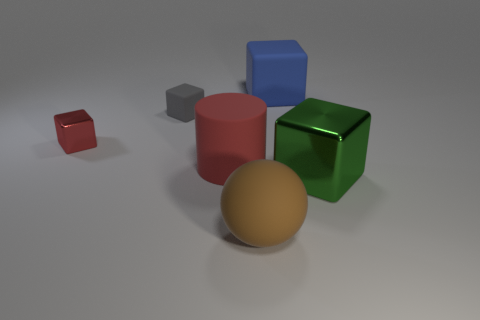Subtract all big rubber cubes. How many cubes are left? 3 Subtract 3 blocks. How many blocks are left? 1 Add 1 big cyan objects. How many objects exist? 7 Subtract all cylinders. How many objects are left? 5 Subtract all cyan cylinders. How many green blocks are left? 1 Subtract all tiny metallic things. Subtract all matte cylinders. How many objects are left? 4 Add 3 small rubber things. How many small rubber things are left? 4 Add 5 large purple rubber blocks. How many large purple rubber blocks exist? 5 Subtract all blue blocks. How many blocks are left? 3 Subtract 0 green cylinders. How many objects are left? 6 